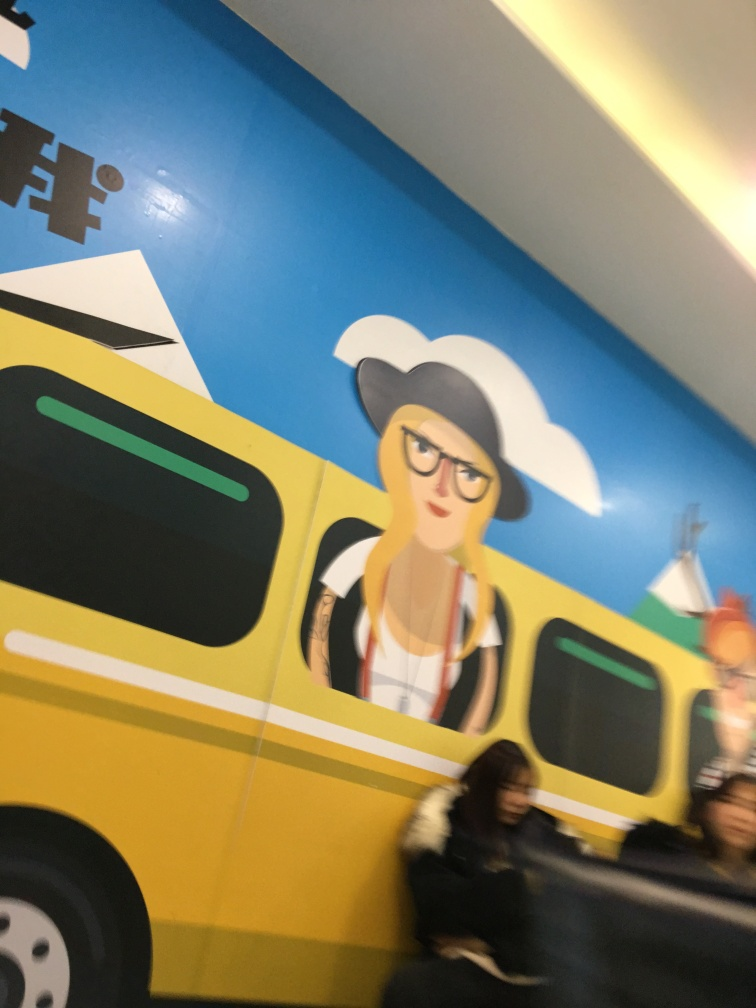What is the style of the art depicted in the image? The art style in the image appears to be a simplified and stylized illustration, using flat colors and minimal shading to create a bold and graphic representation. It has characteristics commonly associated with mural art or pop culture references. 